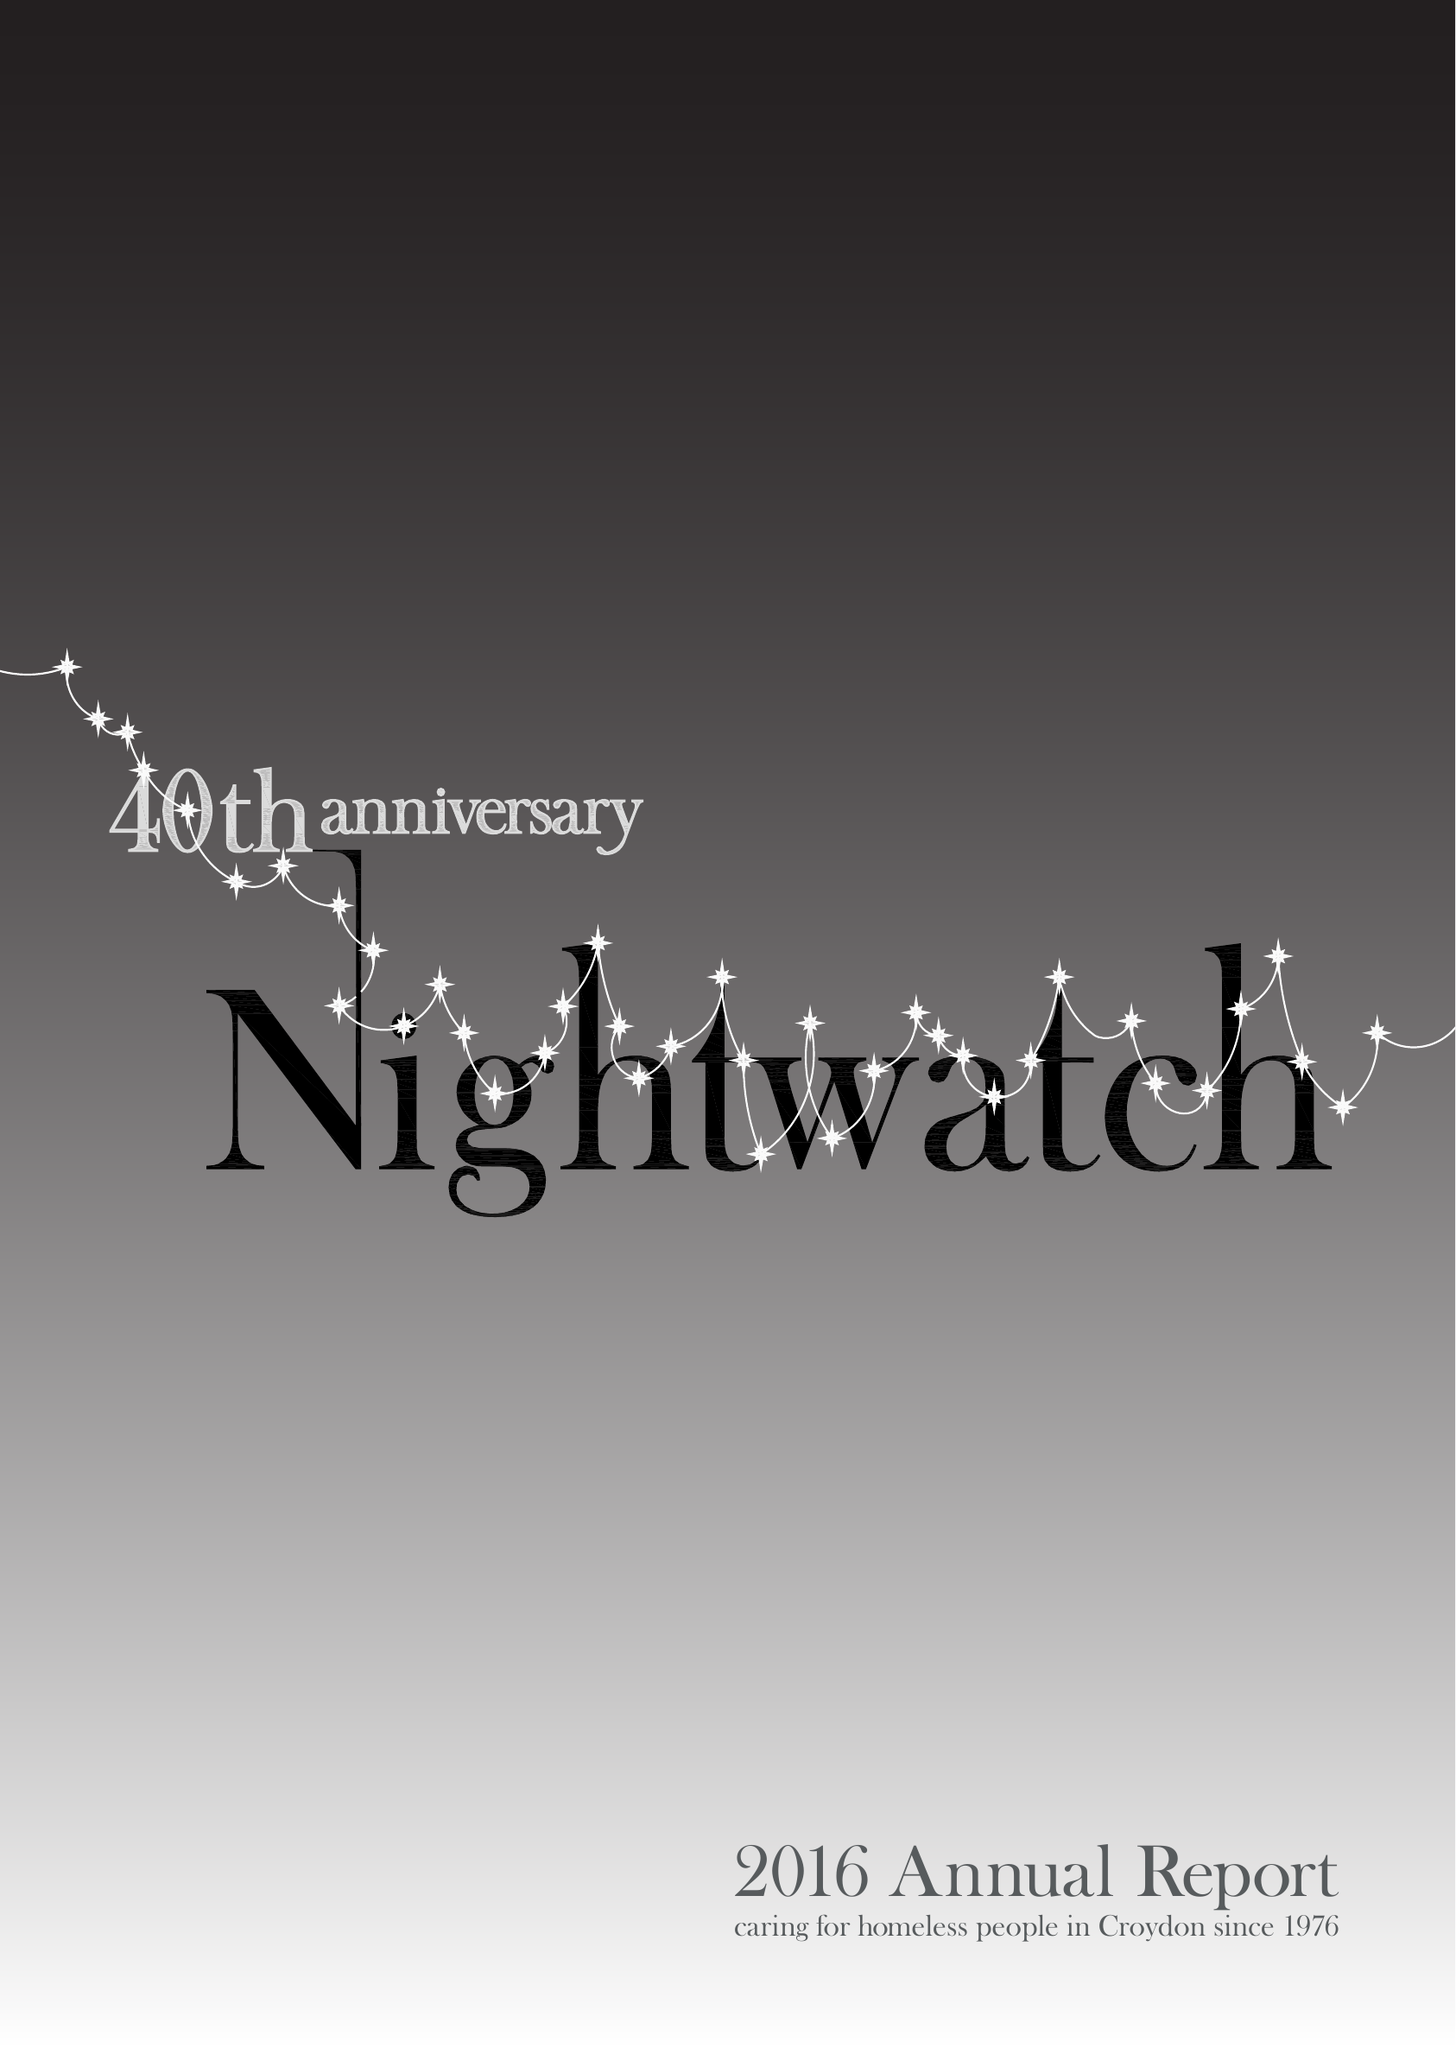What is the value for the charity_name?
Answer the question using a single word or phrase. Nightwatch 